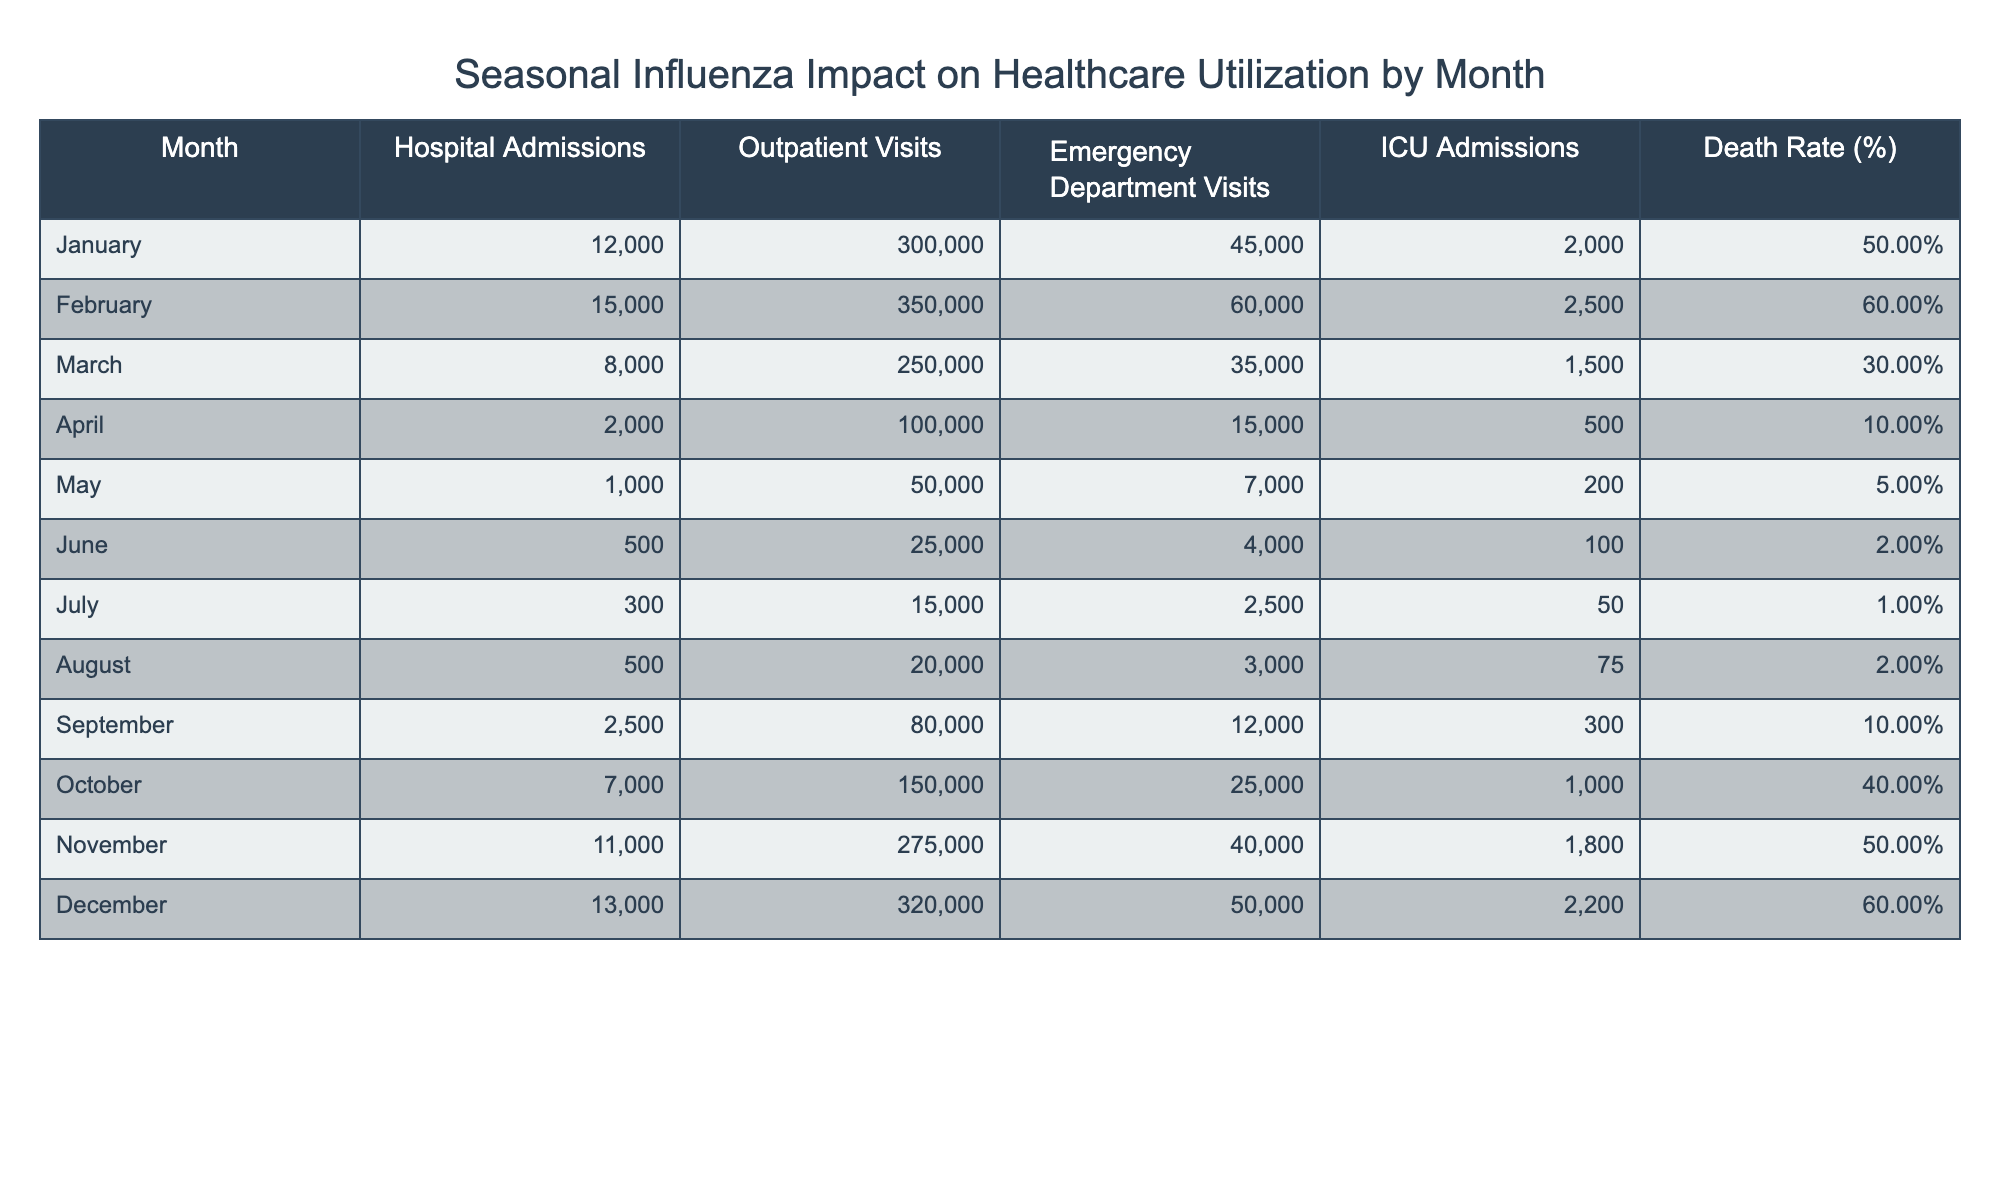What month had the highest number of hospital admissions? By reviewing the "Hospital Admissions" column, we can see the values for each month. February has 15,000, which is the highest number compared to all other months.
Answer: February What is the average death rate across all months? To calculate the average, sum the death rates for all months: (0.5 + 0.6 + 0.3 + 0.1 + 0.05 + 0.02 + 0.01 + 0.02 + 0.1 + 0.4 + 0.5 + 0.6) = 3.63. Then, divide this by the number of months, which is 12: 3.63/12 = 0.3025. The average death rate is approximately 0.30 or 30.25%.
Answer: 0.30 In which month did the emergency department visits exceed 50,000? Looking at the "Emergency Department Visits" column, we find that the numbers exceed 50,000 in January (45,000), February (60,000), November (40,000), and December (50,000). Therefore, February is the only month where visits exceed 50,000.
Answer: February Did outpatient visits increase from April to May? Comparing the "Outpatient Visits" for April (100,000) and May (50,000), we notice that outpatient visits decreased from April to May.
Answer: No What was the total number of hospital admissions from January to March? To find the total admissions from January to March, we add the hospital admissions for each of these months: (12,000 + 15,000 + 8,000) = 35,000.
Answer: 35,000 Which months had more than 2000 ICU admissions? Looking at the "ICU Admissions" column, values greater than 2000 are found in January (2000), February (2500), October (1000), November (1800), and December (2200). Thus, the months over 2000 are February and December.
Answer: February, December What is the difference in outpatient visits between June and July? The outpatient visits in June are 25,000 and in July are 15,000. The difference is calculated by subtracting July's visits from June's: 25,000 - 15,000 = 10,000.
Answer: 10,000 Which month has the lowest death rate? Reviewing the "Death Rate (%)" column, the lowest value is in July (0.01%), indicating that month had the least impact in terms of mortality.
Answer: July How many emergency department visits did September have compared to October? By analyzing the respective values in the "Emergency Department Visits" column: September has 12,000 visits and October has 25,000 visits. To find the comparison, we calculate: 25,000 - 12,000 = 13,000 more visits in October than in September.
Answer: 13,000 